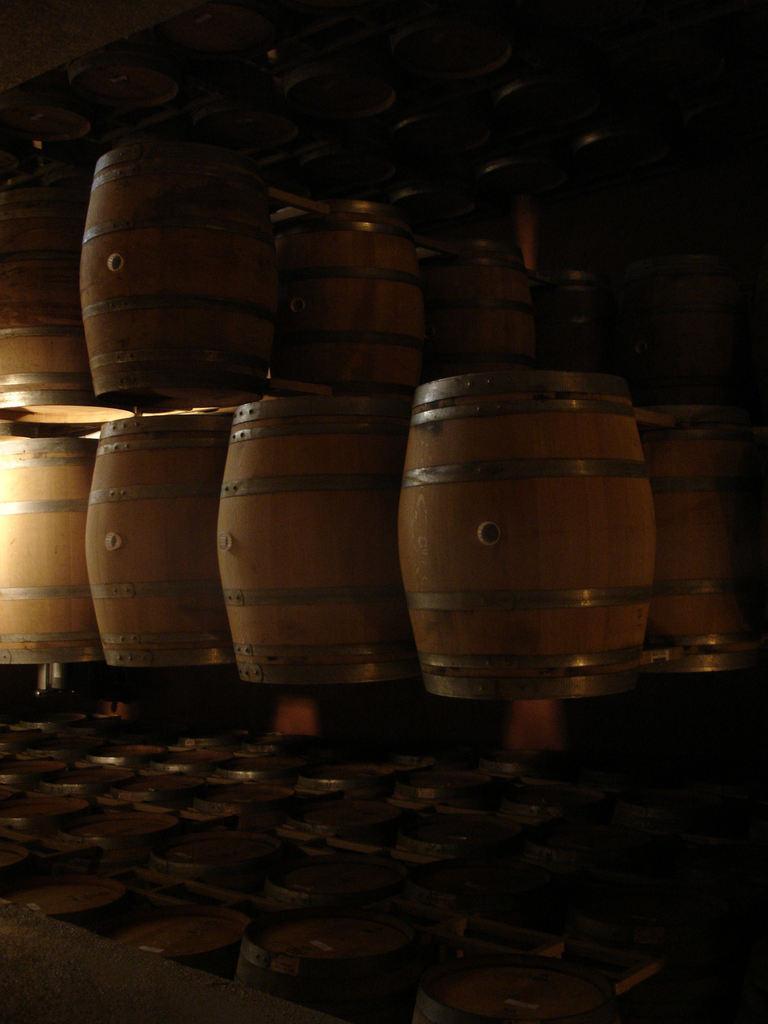Please provide a concise description of this image. In this image we can see barrels placed in the rows. 